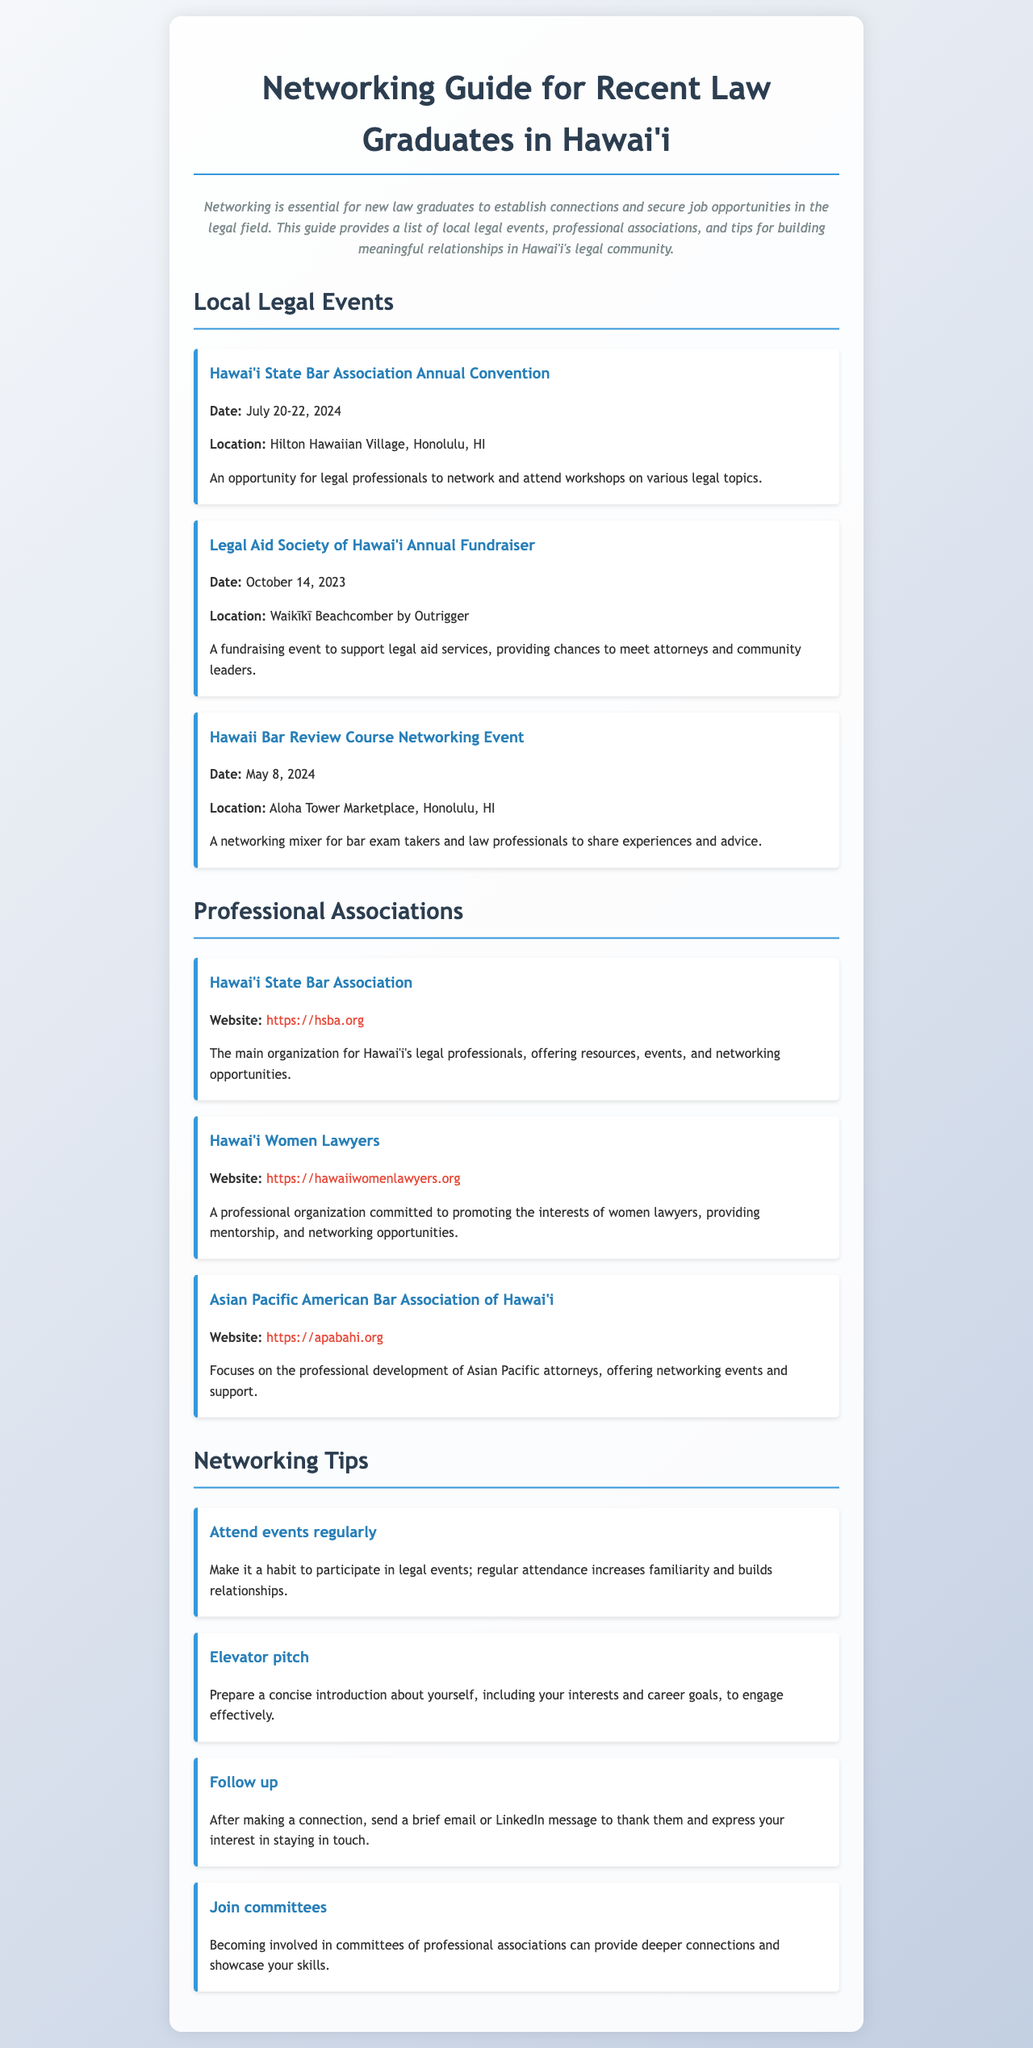What is the date of the Hawai'i State Bar Association Annual Convention? The date is clearly mentioned in the document as July 20-22, 2024.
Answer: July 20-22, 2024 Where is the Legal Aid Society of Hawai'i Annual Fundraiser held? The document specifies the location as Waikīkī Beachcomber by Outrigger.
Answer: Waikīkī Beachcomber by Outrigger What organization focuses on promoting the interests of women lawyers? The document states that Hawai'i Women Lawyers is the organization committed to this cause.
Answer: Hawai'i Women Lawyers What is one tip mentioned for networking? The document offers several tips, one of which is to "Follow up" after making a connection.
Answer: Follow up Which professional association's website is listed as "https://apabahi.org"? The document indicates that this website belongs to the Asian Pacific American Bar Association of Hawai'i.
Answer: Asian Pacific American Bar Association of Hawai'i When is the Hawaii Bar Review Course Networking Event? The date for the event is provided as May 8, 2024.
Answer: May 8, 2024 What is the primary purpose of networking for new law graduates? The document outlines that networking helps establish connections and secure job opportunities.
Answer: Establish connections and secure job opportunities What is the title of the first event listed under Local Legal Events? The first event listed is the Hawai'i State Bar Association Annual Convention.
Answer: Hawai'i State Bar Association Annual Convention 